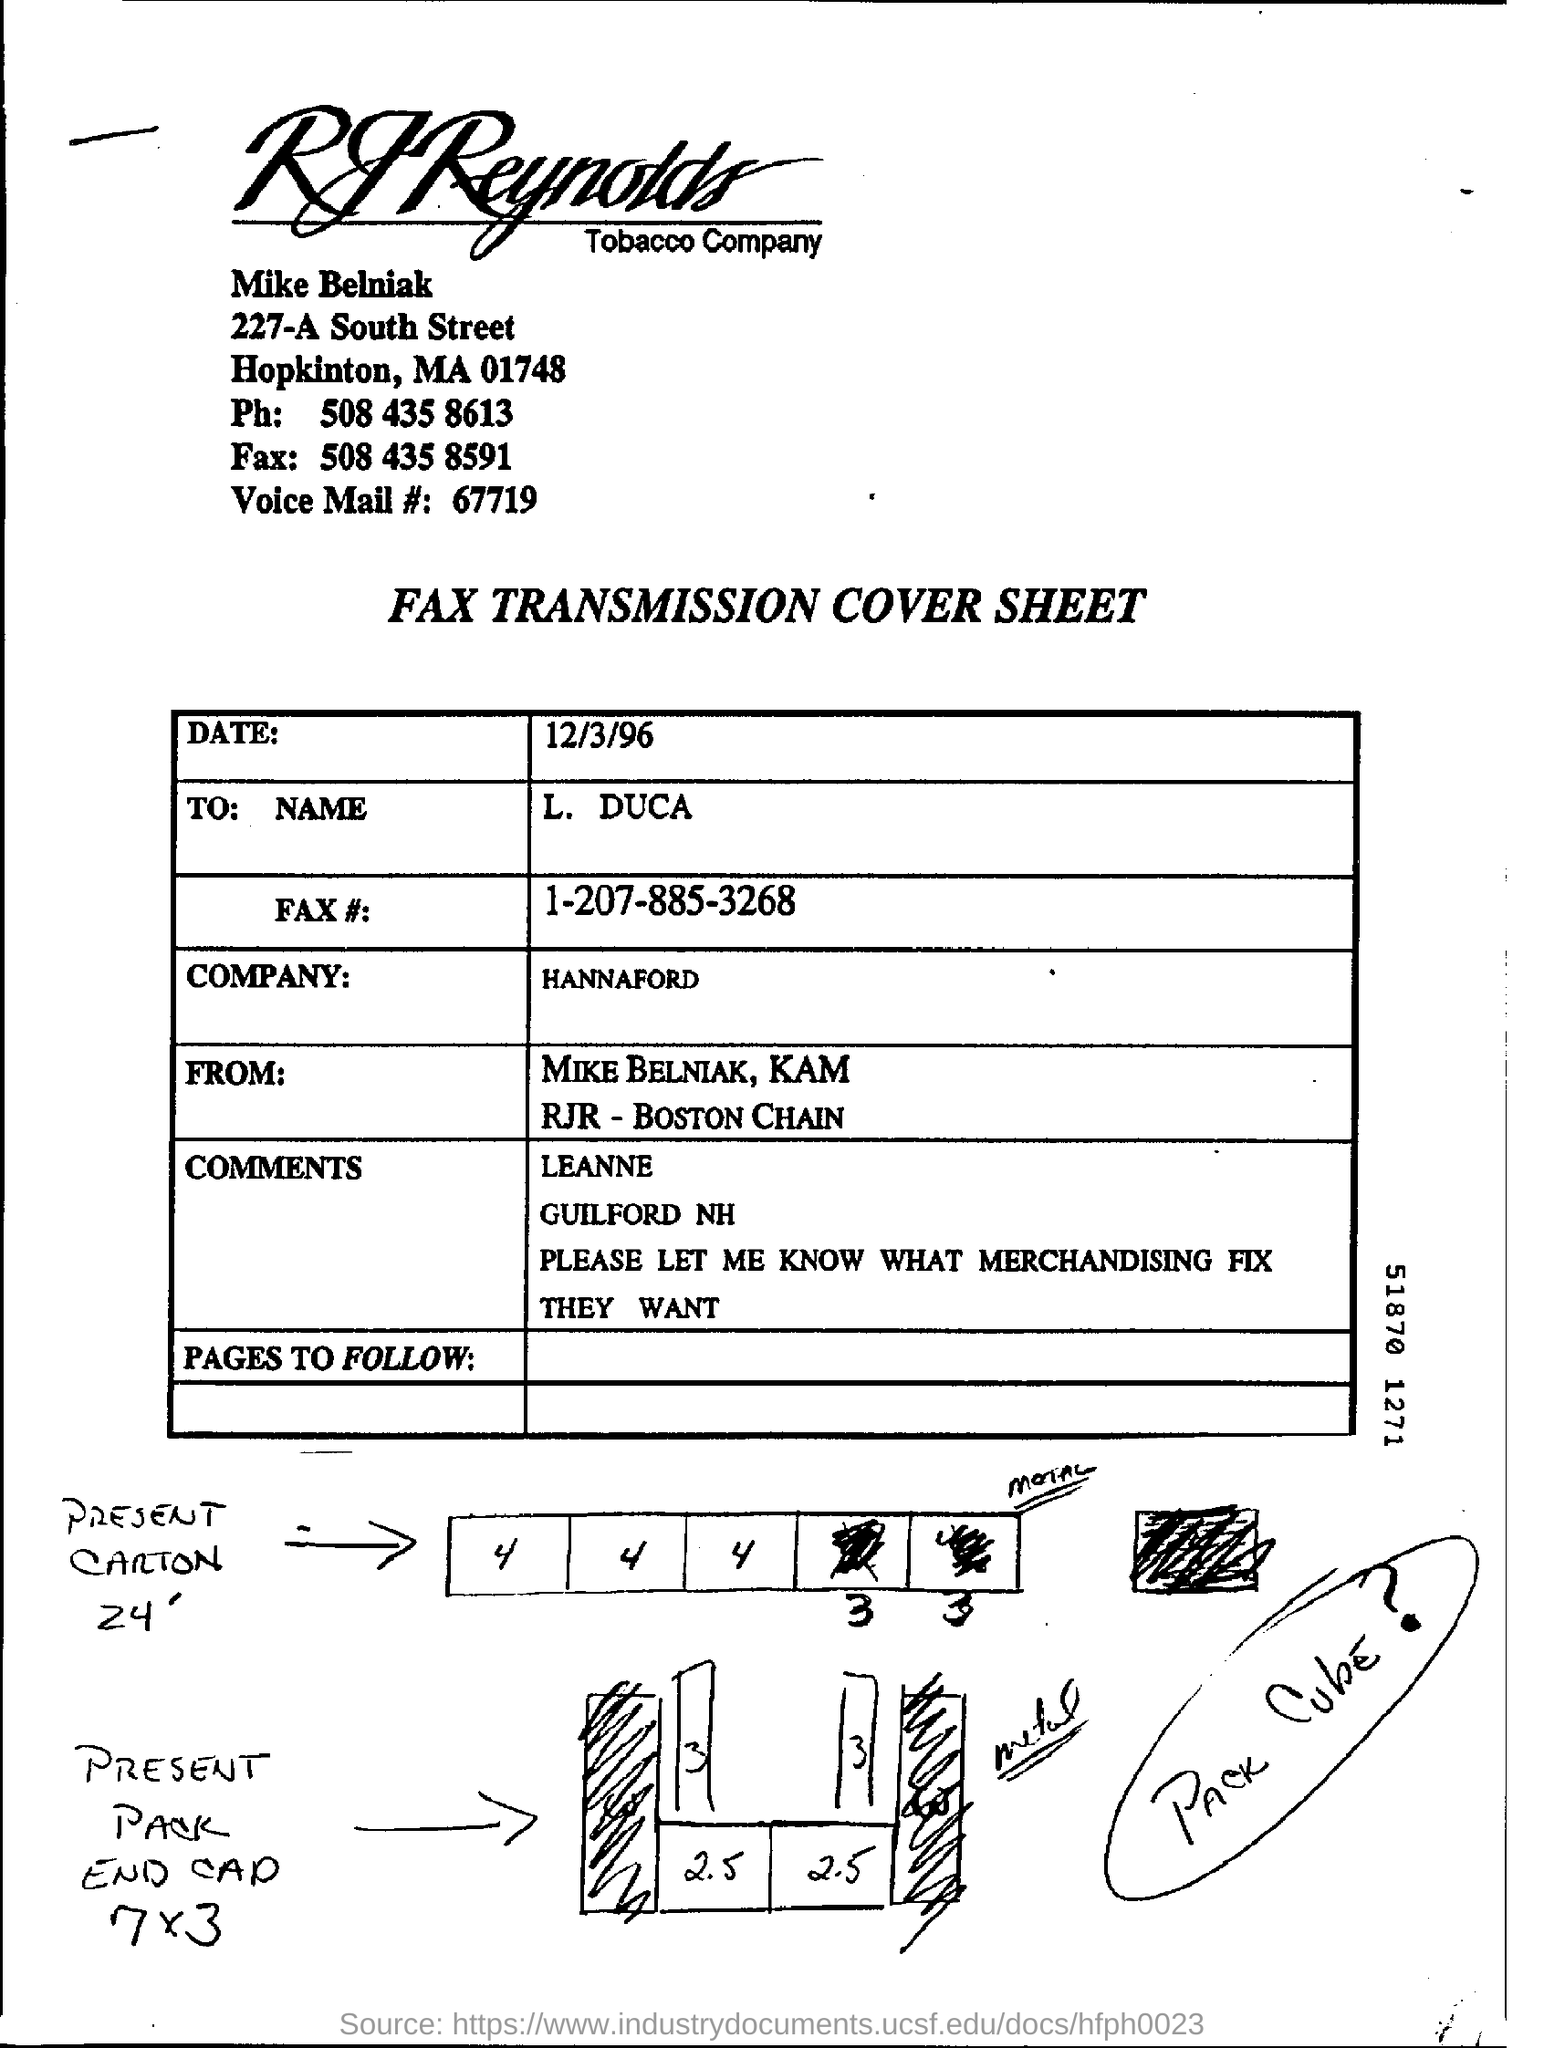Give some essential details in this illustration. I am searching for the fax number of Mike Belniak, which is 508 435 8591. I am seeking the phone number of Mike Belniak, which is 508 435 8613. 